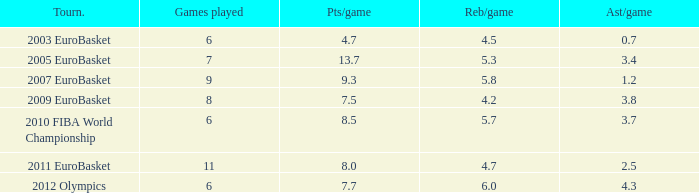Can you parse all the data within this table? {'header': ['Tourn.', 'Games played', 'Pts/game', 'Reb/game', 'Ast/game'], 'rows': [['2003 EuroBasket', '6', '4.7', '4.5', '0.7'], ['2005 EuroBasket', '7', '13.7', '5.3', '3.4'], ['2007 EuroBasket', '9', '9.3', '5.8', '1.2'], ['2009 EuroBasket', '8', '7.5', '4.2', '3.8'], ['2010 FIBA World Championship', '6', '8.5', '5.7', '3.7'], ['2011 EuroBasket', '11', '8.0', '4.7', '2.5'], ['2012 Olympics', '6', '7.7', '6.0', '4.3']]} How many games played have 4.7 as points per game? 6.0. 